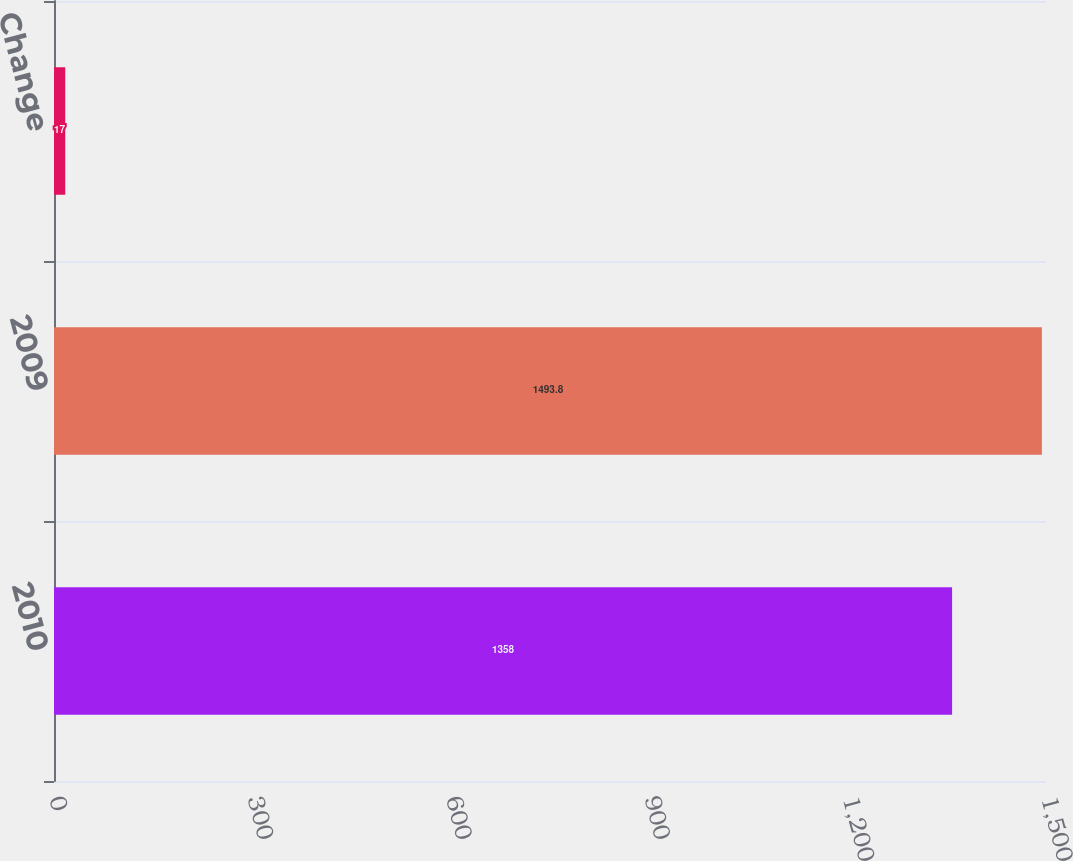Convert chart to OTSL. <chart><loc_0><loc_0><loc_500><loc_500><bar_chart><fcel>2010<fcel>2009<fcel>Change<nl><fcel>1358<fcel>1493.8<fcel>17<nl></chart> 